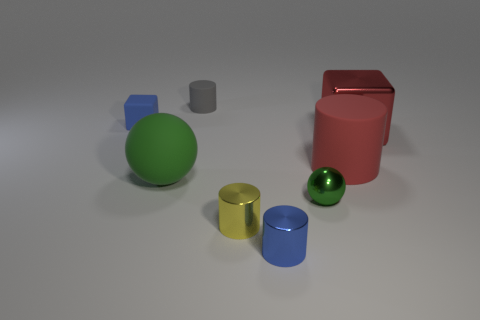Subtract all blue cylinders. How many cylinders are left? 3 Add 1 red rubber cylinders. How many objects exist? 9 Subtract 1 cylinders. How many cylinders are left? 3 Subtract all gray cylinders. How many cylinders are left? 3 Subtract all balls. How many objects are left? 6 Subtract all purple cylinders. Subtract all green blocks. How many cylinders are left? 4 Add 2 tiny blue cylinders. How many tiny blue cylinders exist? 3 Subtract 0 gray balls. How many objects are left? 8 Subtract all green shiny spheres. Subtract all big red shiny cubes. How many objects are left? 6 Add 8 big cylinders. How many big cylinders are left? 9 